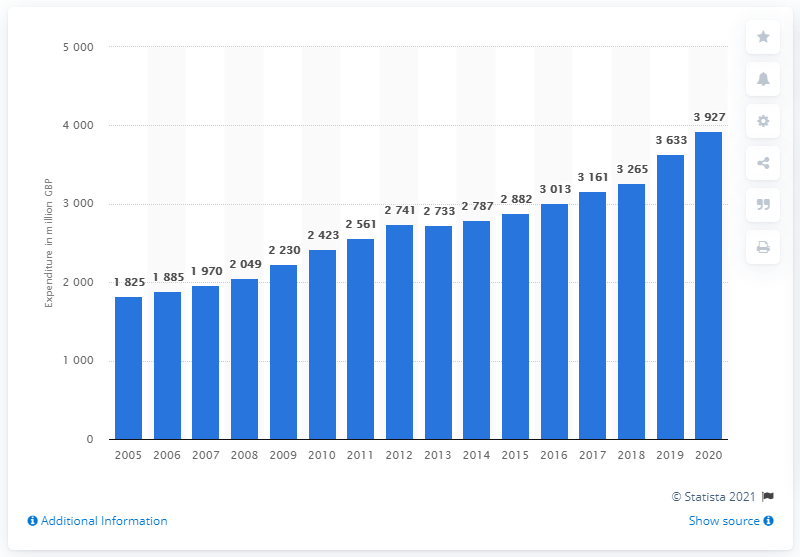Mention a couple of crucial points in this snapshot. In 2020, the total consumer spending on coffee, cocoa, and tea in the UK was £39.27 billion. 